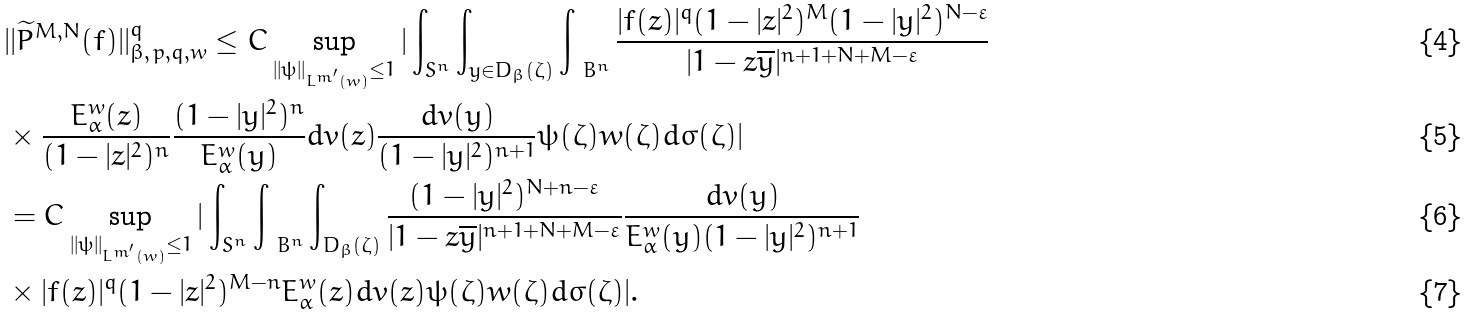<formula> <loc_0><loc_0><loc_500><loc_500>& | | \widetilde { P } ^ { M , N } ( f ) | | _ { \beta , \, p , q , w } ^ { q } \leq C \sup _ { | | \psi | | _ { L ^ { m ^ { \prime } } ( w ) } \leq 1 } | \int _ { { S } ^ { n } } \int _ { y \in D _ { \beta } ( \zeta ) } \int _ { \ B ^ { n } } \frac { | f ( z ) | ^ { q } ( 1 - | z | ^ { 2 } ) ^ { M } ( 1 - | y | ^ { 2 } ) ^ { N - \varepsilon } } { | 1 - z \overline { y } | ^ { n + 1 + N + M - \varepsilon } } \\ & \times \frac { E _ { \alpha } ^ { w } ( z ) } { ( 1 - | z | ^ { 2 } ) ^ { n } } \frac { ( 1 - | y | ^ { 2 } ) ^ { n } } { E _ { \alpha } ^ { w } ( y ) } d v ( z ) \frac { d v ( y ) } { ( 1 - | y | ^ { 2 } ) ^ { n + 1 } } \psi ( \zeta ) w ( \zeta ) d \sigma ( \zeta ) | \\ & = C \sup _ { | | \psi | | _ { L ^ { m ^ { \prime } } ( w ) } \leq 1 } | \int _ { { S } ^ { n } } \int _ { \ B ^ { n } } \int _ { D _ { \beta } ( \zeta ) } \frac { ( 1 - | y | ^ { 2 } ) ^ { N + n - \varepsilon } } { | 1 - z \overline { y } | ^ { n + 1 + N + M - \varepsilon } } \frac { d v ( y ) } { E _ { \alpha } ^ { w } ( y ) ( 1 - | y | ^ { 2 } ) ^ { n + 1 } } \\ & \times | f ( z ) | ^ { q } ( 1 - | z | ^ { 2 } ) ^ { M - n } E _ { \alpha } ^ { w } ( z ) d v ( z ) \psi ( \zeta ) w ( \zeta ) d \sigma ( \zeta ) | .</formula> 